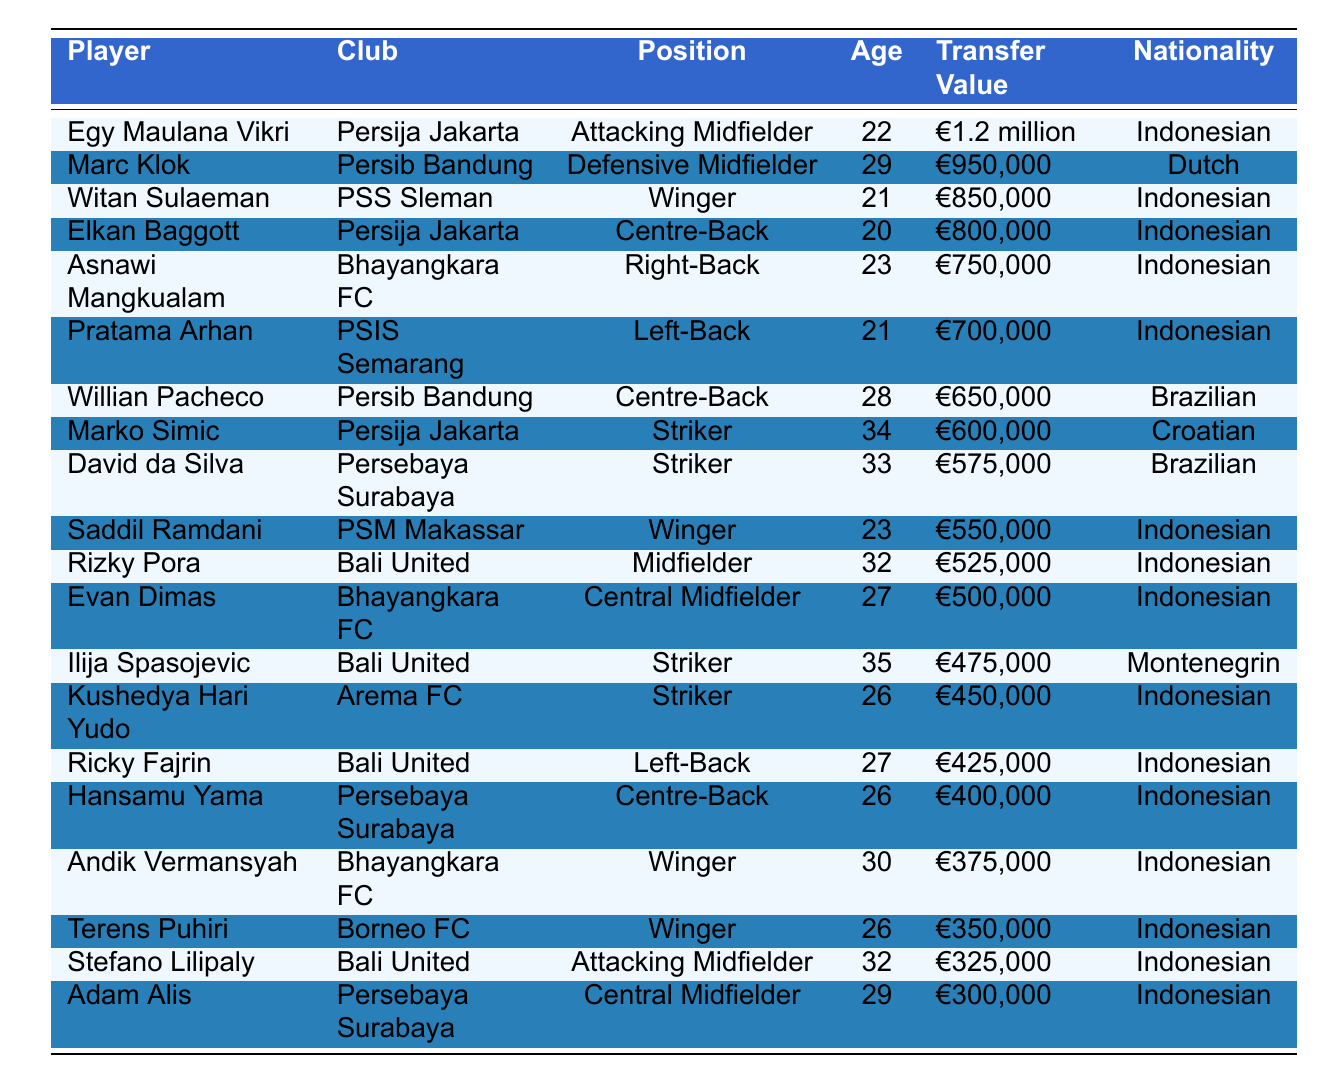What is the transfer value of Egy Maulana Vikri? Egy Maulana Vikri's transfer value is directly listed in the table as €1.2 million.
Answer: €1.2 million Which player has the highest transfer value? Among all the players listed, Egy Maulana Vikri has the highest transfer value of €1.2 million, which can be identified by comparing all the transfer values in the table.
Answer: Egy Maulana Vikri How old is Witan Sulaeman? Witan Sulaeman's age is explicitly mentioned in the table as 21 years.
Answer: 21 Is there a player from Bali United with a transfer value over €500,000? By checking the table, we see that both Rizky Pora (€525,000) and Ilija Spasojevic (€475,000) are listed for Bali United, with only Rizky Pora exceeding €500,000. Hence, the answer is yes.
Answer: Yes What is the average transfer value of the Indonesian players listed? To find the average, first, we list all the Indonesian transfer values: €1.2 million, €850,000, €800,000, €750,000, €700,000, €550,000, €525,000, €500,000, €450,000, €425,000, €400,000, €375,000, €350,000, €325,000, and €300,000. Then, we convert these to a common unit (euros) and sum them up, which gives €1,200,000 + €850,000 + €800,000 + €750,000 + €700,000 + €550,000 + €525,000 + €500,000 + €450,000 + €425,000 + €400,000 + €375,000 + €350,000 + €325,000 + €300,000 = €10,450,000. Now we divide by the number of Indonesian players (15), resulting in an average of €10,450,000 / 15 = €696,667.
Answer: €696,667 How many players listed are strikers? The table shows three players whose position is labeled as Striker: Marko Simic, David da Silva, and Kushedya Hari Yudo, making a total of three strikers.
Answer: 3 What nationality is the player with the lowest transfer value? Looking through the table, Adam Alis is identified as having the lowest transfer value of €300,000, and he is Indonesian, which is confirmed by his nationality listed in the table.
Answer: Indonesian Is Marc Klok older than Saddil Ramdani? The table shows Marc Klok is 29 years old while Saddil Ramdani is 23. Since 29 is greater than 23, this implies that Marc Klok is indeed older than Saddil Ramdani.
Answer: Yes Count how many players have a transfer value less than €500,000. By examining the transfer values, the players with values under €500,000 are Ilija Spasojevic (€475,000), Kushedya Hari Yudo (€450,000), Ricky Fajrin (€425,000), Hansamu Yama (€400,000), Andik Vermansyah (€375,000), Terens Puhiri (€350,000), Stefano Lilipaly (€325,000), and Adam Alis (€300,000), totaling eight players.
Answer: 8 Which club has the most players listed in the top 20? By checking the clubs associated with each player in the table, we find that Bali United has three players listed (Rizky Pora, Ilija Spasojevic, and Stefano Lilipaly), which is the highest number of players from a single club compared to others.
Answer: Bali United Was there a Centre-Back with a transfer value equal to or greater than €800,000? The only Centre-Backs mentioned are Elkan Baggott (€800,000) and Willian Pacheco (€650,000). Since Elkan Baggott meets the condition with an equal transfer value of €800,000, the answer is yes.
Answer: Yes 